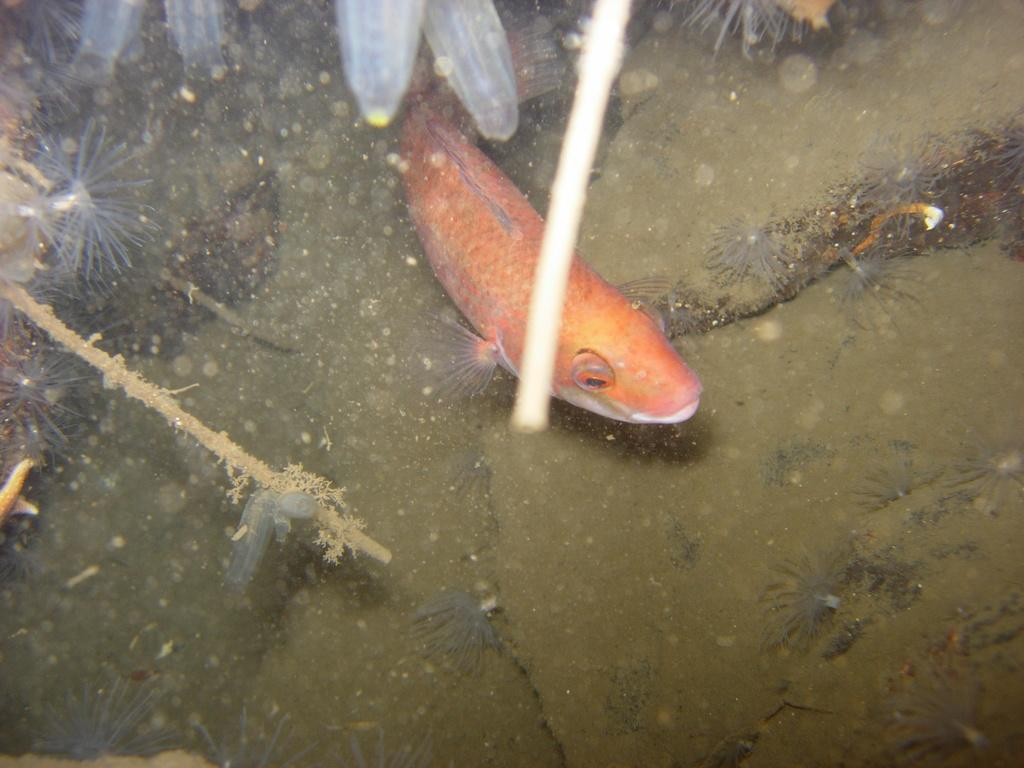What type of animal is in the image? There is a fish in the image. What is the primary element in which the fish is situated? There is water in the image. What other living organisms can be seen in the image? There are plants in the image. What type of pickle is being exchanged between the fish in the image? There is no pickle present in the image, nor is there any exchange happening between the fish. 